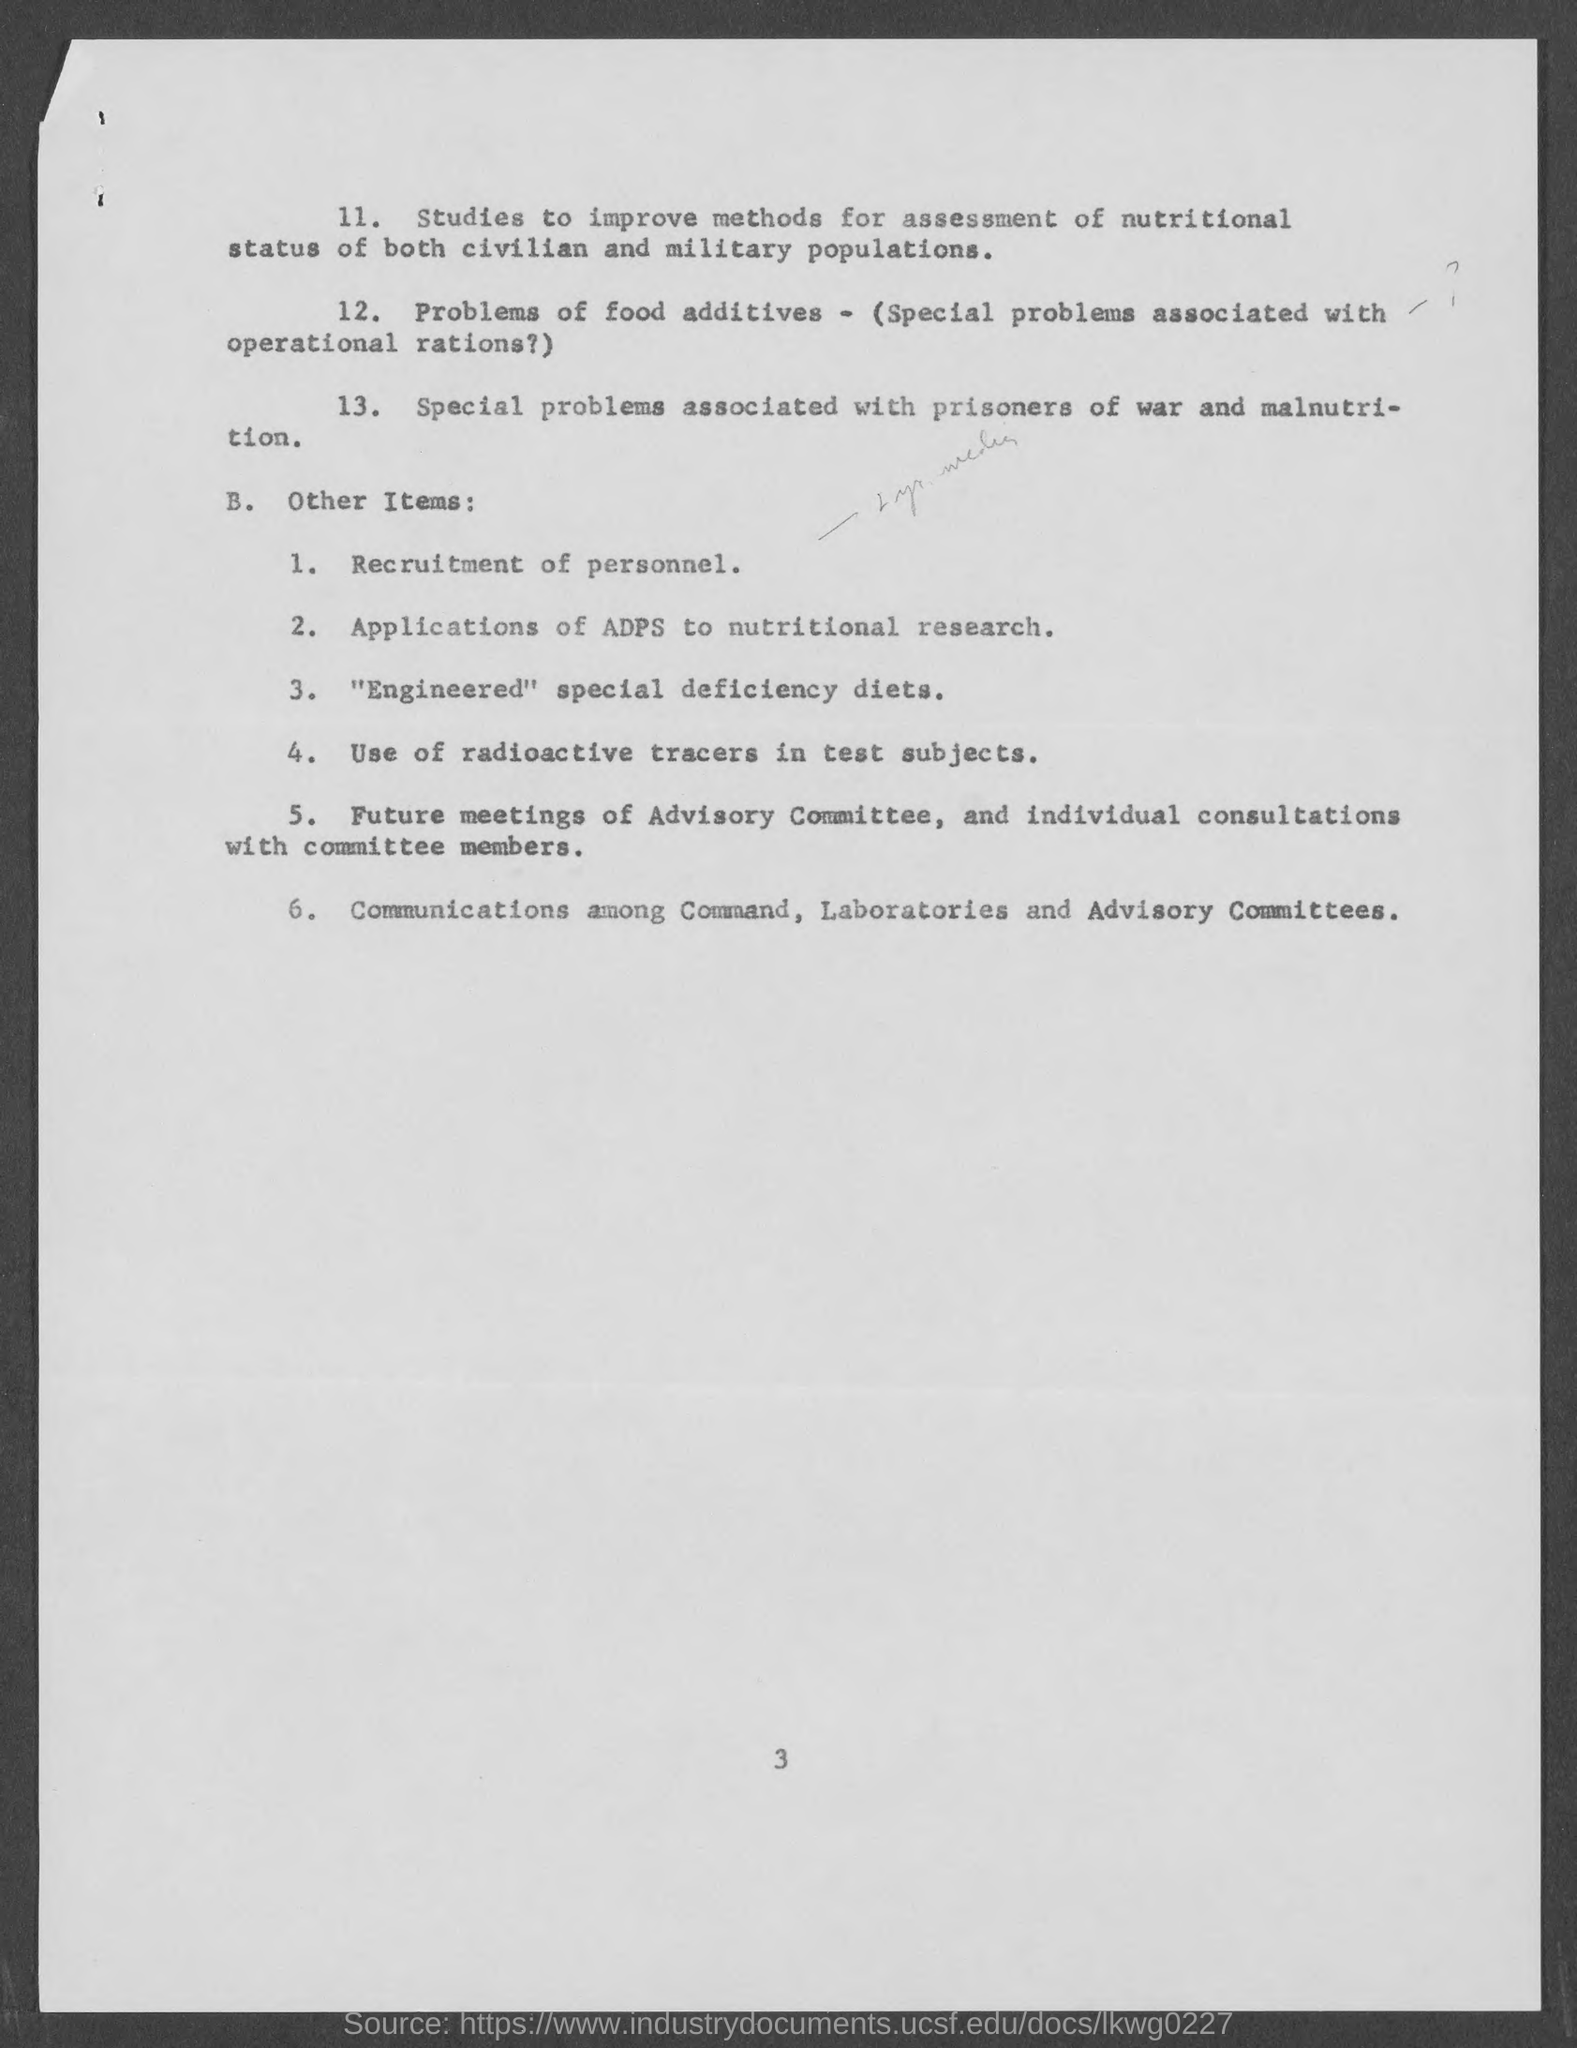What is the page number mentioned at bottom of the page?
Provide a short and direct response. 3. 